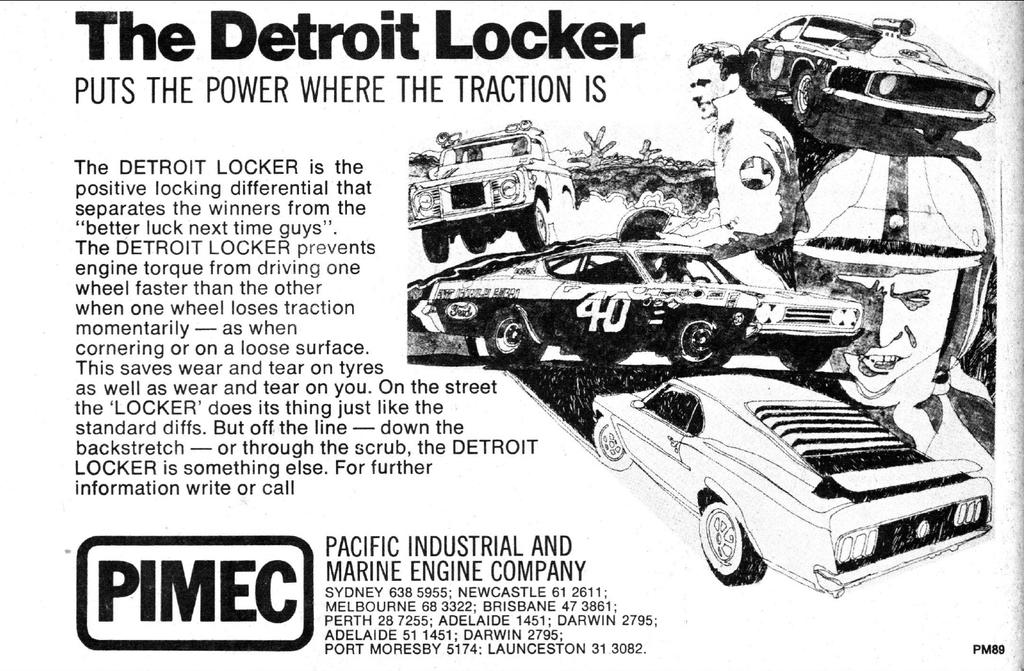What type of picture is in the image? The image contains a black and white picture. What is shown in the black and white picture? The black and white picture depicts two men. What can be seen on the right side of the image? There are cars on the right side of the image. Where is the text located in the image? There is text on the left side of the image. What type of bomb is hidden in the room depicted in the image? There is no room or bomb present in the image; it contains a black and white picture of two men, cars on the right side, and text on the left side. 